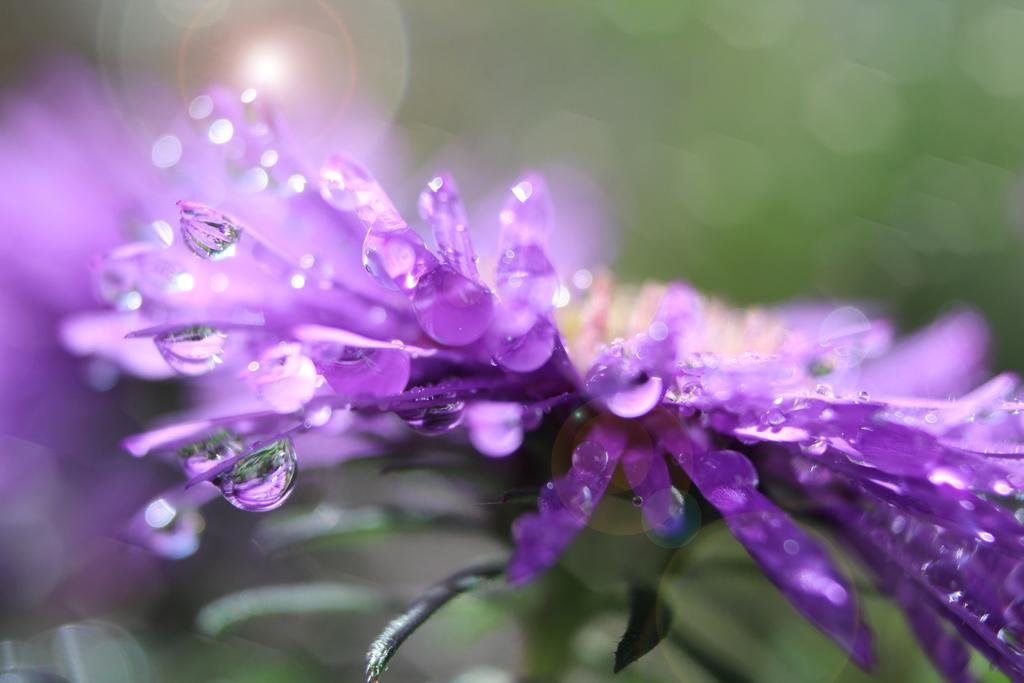What is the main subject of the image? There is a flower in the image. What color is the flower? The flower is lavender in color. Can you describe any additional details about the flower? Yes, there are water drops on the flower. How would you describe the background of the image? The background of the image appears blurry. How much wealth does the flower possess in the image? The flower does not possess wealth in the image, as it is an inanimate object and cannot own or accumulate wealth. 